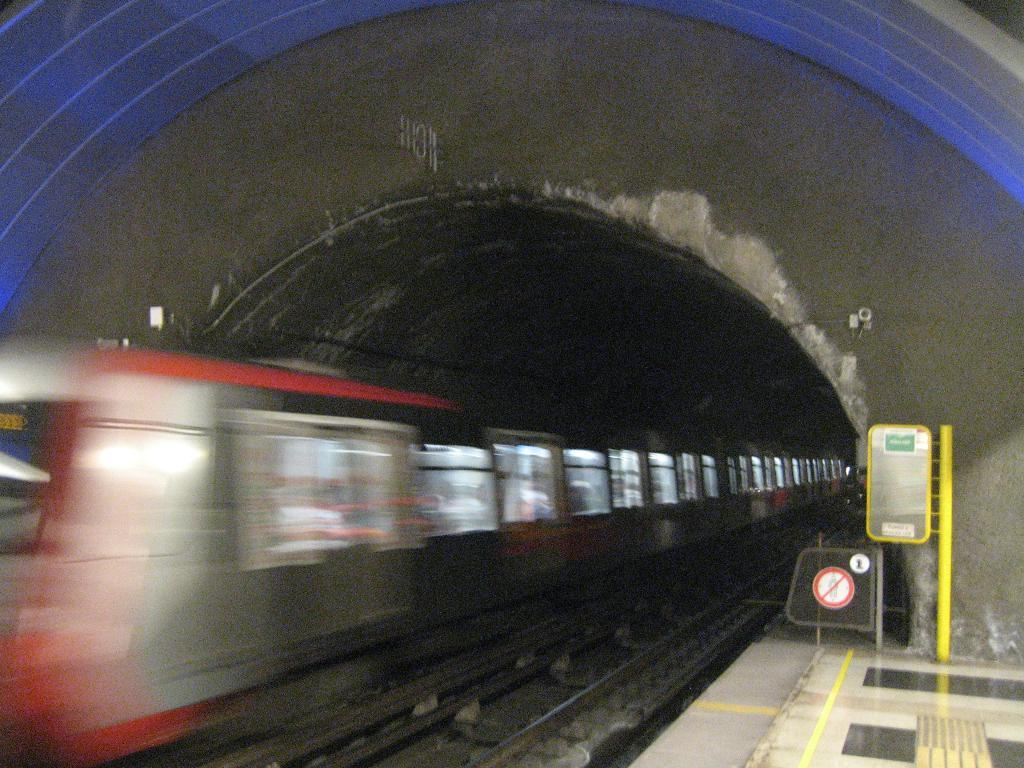What is the main subject of the image? The main subject of the image is a train. Where is the train located in the image? The train is on a track in the image. What feature is present in the background of the image? There is a tunnel in the image. What objects can be seen near the train? There are boards and a pole visible in the image. What type of dress is the train wearing in the image? Trains do not wear dresses; they are inanimate objects. 